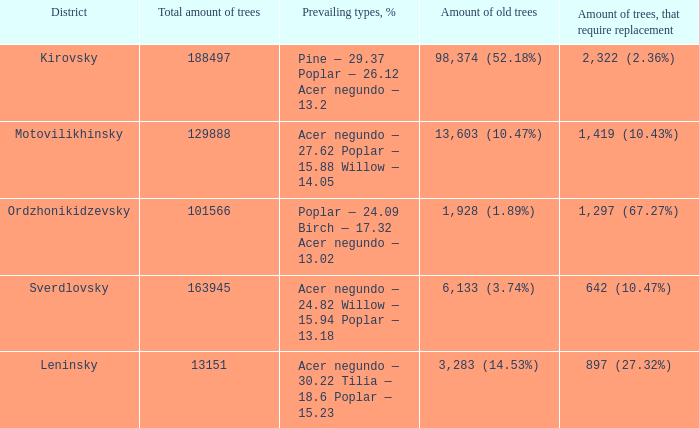How many trees are present in the leninsky district altogether? 13151.0. Write the full table. {'header': ['District', 'Total amount of trees', 'Prevailing types, %', 'Amount of old trees', 'Amount of trees, that require replacement'], 'rows': [['Kirovsky', '188497', 'Pine — 29.37 Poplar — 26.12 Acer negundo — 13.2', '98,374 (52.18%)', '2,322 (2.36%)'], ['Motovilikhinsky', '129888', 'Acer negundo — 27.62 Poplar — 15.88 Willow — 14.05', '13,603 (10.47%)', '1,419 (10.43%)'], ['Ordzhonikidzevsky', '101566', 'Poplar — 24.09 Birch — 17.32 Acer negundo — 13.02', '1,928 (1.89%)', '1,297 (67.27%)'], ['Sverdlovsky', '163945', 'Acer negundo — 24.82 Willow — 15.94 Poplar — 13.18', '6,133 (3.74%)', '642 (10.47%)'], ['Leninsky', '13151', 'Acer negundo — 30.22 Tilia — 18.6 Poplar — 15.23', '3,283 (14.53%)', '897 (27.32%)']]} 